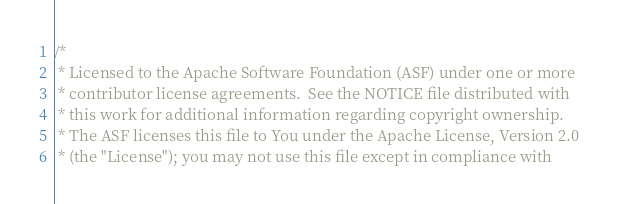<code> <loc_0><loc_0><loc_500><loc_500><_Scala_>/*
 * Licensed to the Apache Software Foundation (ASF) under one or more
 * contributor license agreements.  See the NOTICE file distributed with
 * this work for additional information regarding copyright ownership.
 * The ASF licenses this file to You under the Apache License, Version 2.0
 * (the "License"); you may not use this file except in compliance with</code> 